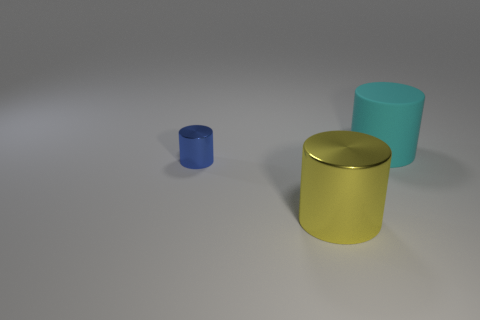Add 2 small cylinders. How many objects exist? 5 Subtract all big cylinders. How many cylinders are left? 1 Subtract 3 cylinders. How many cylinders are left? 0 Add 2 tiny gray shiny spheres. How many tiny gray shiny spheres exist? 2 Subtract all blue cylinders. How many cylinders are left? 2 Subtract 0 cyan balls. How many objects are left? 3 Subtract all red cylinders. Subtract all blue cubes. How many cylinders are left? 3 Subtract all brown spheres. How many cyan cylinders are left? 1 Subtract all yellow metal cylinders. Subtract all small blue cylinders. How many objects are left? 1 Add 3 big cyan objects. How many big cyan objects are left? 4 